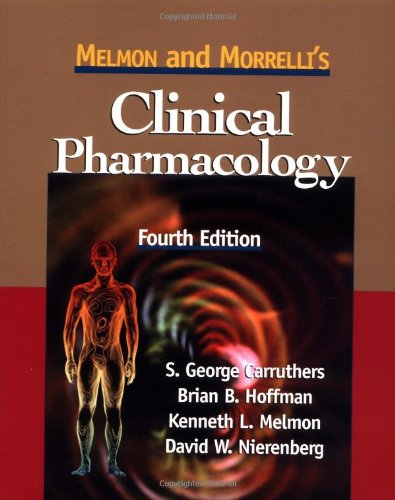Is this a sociopolitical book? No, 'Melmon and Morrelli's Clinical Pharmacology' doesn't cover sociopolitical topics; it is dedicated purely to medical and pharmacological studies. 